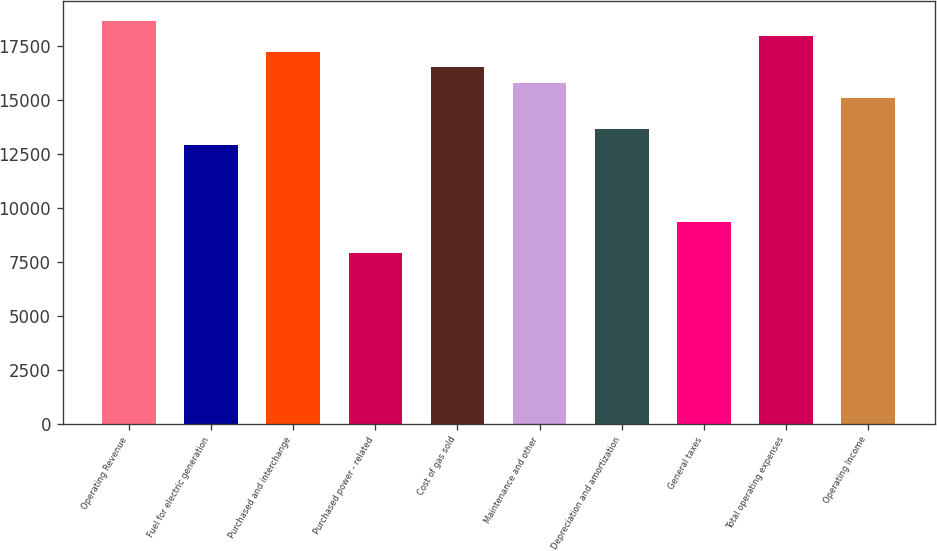Convert chart to OTSL. <chart><loc_0><loc_0><loc_500><loc_500><bar_chart><fcel>Operating Revenue<fcel>Fuel for electric generation<fcel>Purchased and interchange<fcel>Purchased power - related<fcel>Cost of gas sold<fcel>Maintenance and other<fcel>Depreciation and amortization<fcel>General taxes<fcel>Total operating expenses<fcel>Operating Income<nl><fcel>18662.7<fcel>12920.9<fcel>17227.3<fcel>7896.77<fcel>16509.5<fcel>15791.8<fcel>13638.6<fcel>9332.23<fcel>17945<fcel>15074.1<nl></chart> 